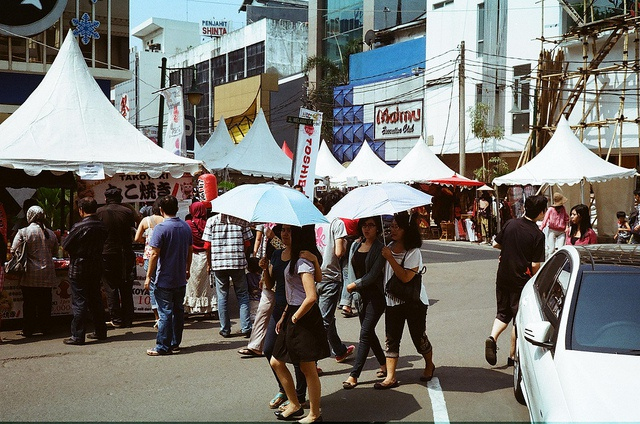Describe the objects in this image and their specific colors. I can see car in black, white, gray, and darkblue tones, umbrella in black, white, darkgray, and gray tones, people in black, gray, lightgray, and maroon tones, people in black, maroon, and gray tones, and people in black, maroon, darkgray, and gray tones in this image. 